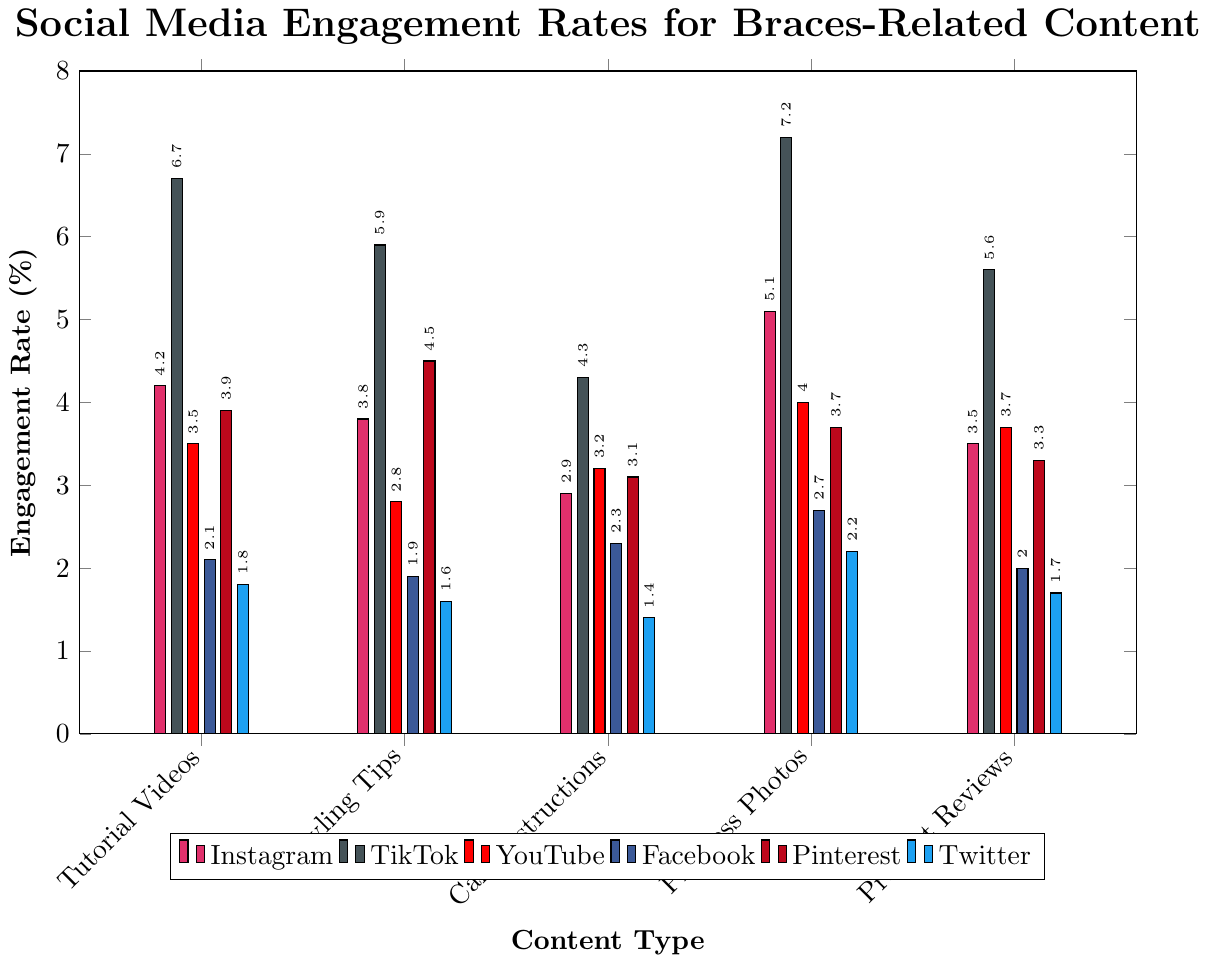Which platform has the highest engagement rate for tutorial videos? To determine which platform has the highest engagement rate for tutorial videos, compare the values for tutorial videos across all platforms. TikTok has the highest engagement rate of 6.7%.
Answer: TikTok What is the difference in engagement rates between styling tips on Pinterest and Instagram? Find the engagement rates for styling tips on both Pinterest and Instagram, which are 4.5% and 3.8% respectively, and then subtract the Instagram rate from the Pinterest rate. 4.5% - 3.8% = 0.7%.
Answer: 0.7% Which types of braces-related content have the highest engagement rates on average across all platforms? Calculate the average engagement rate for each content type by summing the rates across all platforms and dividing by the number of platforms. The content types and their average rates are: Tutorial Videos (4.03%), Styling Tips (3.75%), Care Instructions (2.87%), Progress Photos (4.15%), Product Reviews (3.3%). Progress Photos have the highest average engagement rate.
Answer: Progress Photos How much higher is the engagement rate of product reviews on TikTok compared to Twitter? Compare the engagement rates for product reviews between TikTok and Twitter, which are 5.6% and 1.7% respectively, then subtract the rate on Twitter from the rate on TikTok. 5.6% - 1.7% = 3.9%.
Answer: 3.9% Which platform has the lowest engagement rate for care instructions, and what is it? Find the engagement rates for care instructions across all platforms: Instagram (2.9%), TikTok (4.3%), YouTube (3.2%), Facebook (2.3%), Pinterest (3.1%), Twitter (1.4%). The lowest engagement rate is on Twitter.
Answer: Twitter, 1.4% On which platform do styling tips receive a higher engagement rate than care instructions? Compare the engagement rates for styling tips and care instructions for each platform. Styling tips have higher engagement rates than care instructions on these platforms: Instagram (3.8% vs. 2.9%), TikTok (5.9% vs. 4.3%), Pinterest (4.5% vs. 3.1%).
Answer: Instagram, TikTok, Pinterest What is the average engagement rate for progress photos across all platforms? Sum the engagement rates for progress photos across all platforms and divide by the number of platforms. The rates are: Instagram (5.1%), TikTok (7.2%), YouTube (4.0%), Facebook (2.7%), Pinterest (3.7%), Twitter (2.2%), summing them gives 24.9%; dividing by 6 platforms gives 24.9% / 6 = 4.15%.
Answer: 4.15% Which platform shows the smallest difference in engagement rates between tutorial videos and product reviews? For each platform, calculate the absolute difference between the engagement rates of tutorial videos and product reviews: Instagram (0.7%), TikTok (1.1%), YouTube (0.2%), Facebook (0.1%), Pinterest (0.6%), Twitter (0.1%). The smallest difference is on Facebook and Twitter with 0.1%.
Answer: Facebook, Twitter 